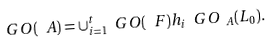<formula> <loc_0><loc_0><loc_500><loc_500>\ G O ( \ A ) = \cup _ { i = 1 } ^ { t } \ G O ( \ F ) h _ { i } \ G O _ { \ A } ( L _ { 0 } ) .</formula> 